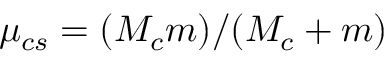Convert formula to latex. <formula><loc_0><loc_0><loc_500><loc_500>\mu _ { c s } = ( M _ { c } m ) / ( M _ { c } + m )</formula> 